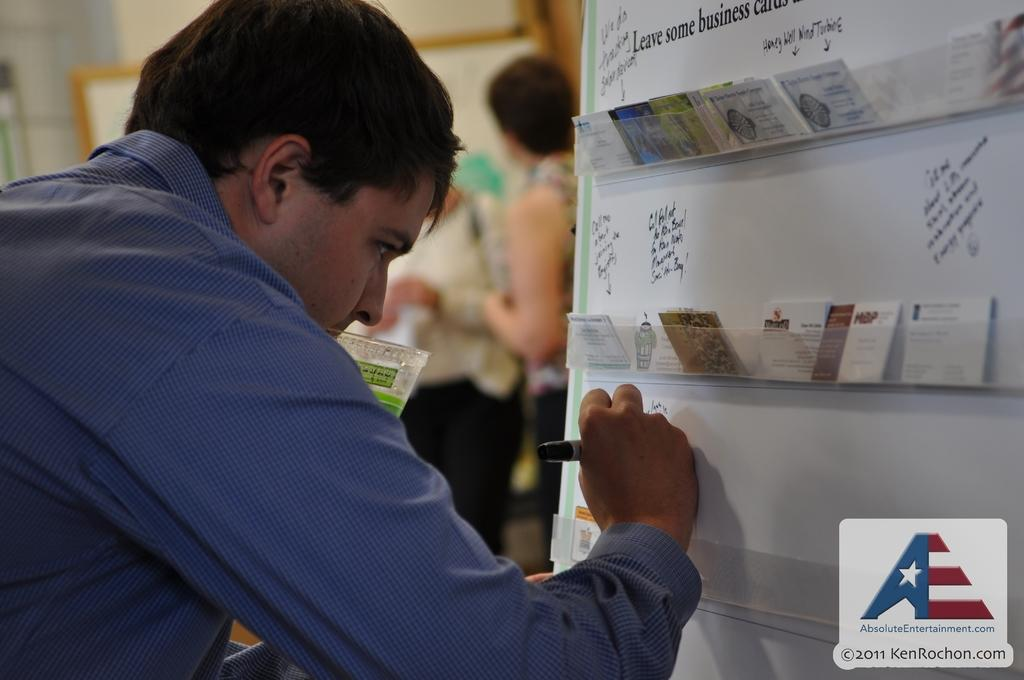<image>
Describe the image concisely. A man writes on a whiteboard that says to Leave some business cards at the top. 